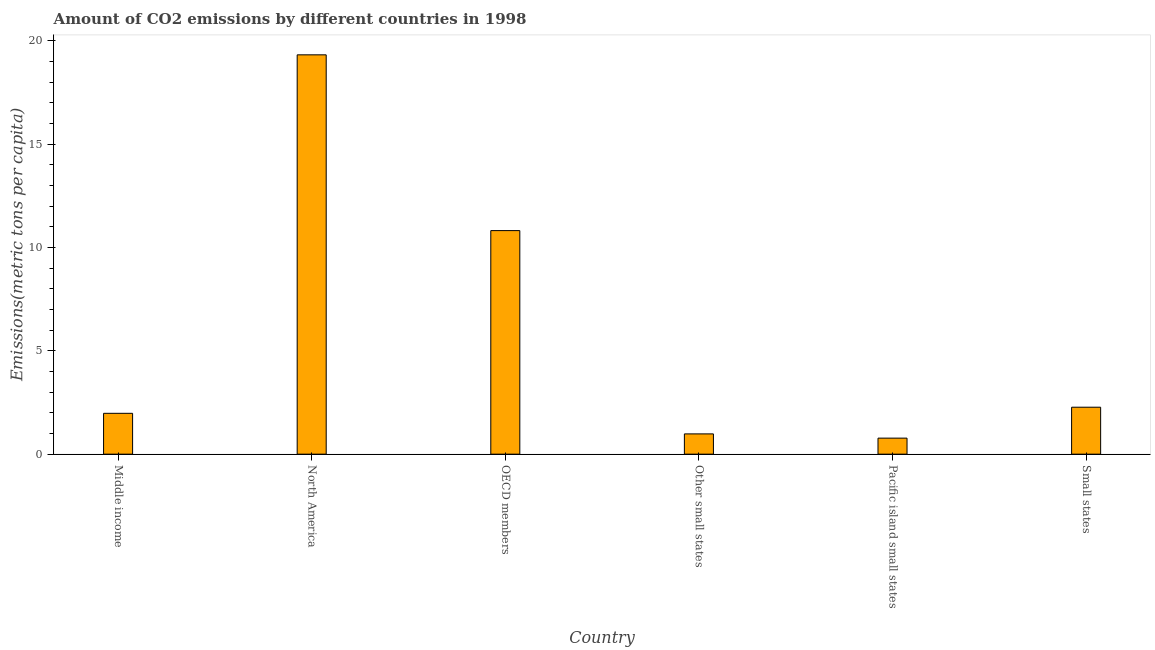Does the graph contain any zero values?
Make the answer very short. No. Does the graph contain grids?
Your answer should be very brief. No. What is the title of the graph?
Ensure brevity in your answer.  Amount of CO2 emissions by different countries in 1998. What is the label or title of the X-axis?
Offer a terse response. Country. What is the label or title of the Y-axis?
Offer a very short reply. Emissions(metric tons per capita). What is the amount of co2 emissions in North America?
Give a very brief answer. 19.33. Across all countries, what is the maximum amount of co2 emissions?
Provide a succinct answer. 19.33. Across all countries, what is the minimum amount of co2 emissions?
Provide a short and direct response. 0.78. In which country was the amount of co2 emissions minimum?
Provide a succinct answer. Pacific island small states. What is the sum of the amount of co2 emissions?
Provide a short and direct response. 36.16. What is the difference between the amount of co2 emissions in Middle income and Pacific island small states?
Your response must be concise. 1.2. What is the average amount of co2 emissions per country?
Provide a short and direct response. 6.03. What is the median amount of co2 emissions?
Ensure brevity in your answer.  2.12. In how many countries, is the amount of co2 emissions greater than 6 metric tons per capita?
Offer a terse response. 2. What is the ratio of the amount of co2 emissions in North America to that in OECD members?
Offer a terse response. 1.79. Is the amount of co2 emissions in Middle income less than that in Small states?
Your answer should be very brief. Yes. Is the difference between the amount of co2 emissions in Pacific island small states and Small states greater than the difference between any two countries?
Provide a short and direct response. No. What is the difference between the highest and the second highest amount of co2 emissions?
Your response must be concise. 8.51. What is the difference between the highest and the lowest amount of co2 emissions?
Provide a succinct answer. 18.55. In how many countries, is the amount of co2 emissions greater than the average amount of co2 emissions taken over all countries?
Offer a terse response. 2. Are all the bars in the graph horizontal?
Ensure brevity in your answer.  No. What is the difference between two consecutive major ticks on the Y-axis?
Offer a very short reply. 5. What is the Emissions(metric tons per capita) in Middle income?
Give a very brief answer. 1.98. What is the Emissions(metric tons per capita) in North America?
Ensure brevity in your answer.  19.33. What is the Emissions(metric tons per capita) in OECD members?
Your answer should be compact. 10.82. What is the Emissions(metric tons per capita) of Other small states?
Your response must be concise. 0.98. What is the Emissions(metric tons per capita) in Pacific island small states?
Provide a succinct answer. 0.78. What is the Emissions(metric tons per capita) of Small states?
Your answer should be compact. 2.27. What is the difference between the Emissions(metric tons per capita) in Middle income and North America?
Keep it short and to the point. -17.35. What is the difference between the Emissions(metric tons per capita) in Middle income and OECD members?
Give a very brief answer. -8.84. What is the difference between the Emissions(metric tons per capita) in Middle income and Other small states?
Make the answer very short. 1. What is the difference between the Emissions(metric tons per capita) in Middle income and Pacific island small states?
Your answer should be compact. 1.2. What is the difference between the Emissions(metric tons per capita) in Middle income and Small states?
Your response must be concise. -0.3. What is the difference between the Emissions(metric tons per capita) in North America and OECD members?
Offer a terse response. 8.51. What is the difference between the Emissions(metric tons per capita) in North America and Other small states?
Keep it short and to the point. 18.35. What is the difference between the Emissions(metric tons per capita) in North America and Pacific island small states?
Make the answer very short. 18.55. What is the difference between the Emissions(metric tons per capita) in North America and Small states?
Keep it short and to the point. 17.06. What is the difference between the Emissions(metric tons per capita) in OECD members and Other small states?
Ensure brevity in your answer.  9.84. What is the difference between the Emissions(metric tons per capita) in OECD members and Pacific island small states?
Provide a short and direct response. 10.05. What is the difference between the Emissions(metric tons per capita) in OECD members and Small states?
Offer a very short reply. 8.55. What is the difference between the Emissions(metric tons per capita) in Other small states and Pacific island small states?
Offer a terse response. 0.21. What is the difference between the Emissions(metric tons per capita) in Other small states and Small states?
Provide a succinct answer. -1.29. What is the difference between the Emissions(metric tons per capita) in Pacific island small states and Small states?
Provide a short and direct response. -1.5. What is the ratio of the Emissions(metric tons per capita) in Middle income to that in North America?
Your answer should be very brief. 0.1. What is the ratio of the Emissions(metric tons per capita) in Middle income to that in OECD members?
Ensure brevity in your answer.  0.18. What is the ratio of the Emissions(metric tons per capita) in Middle income to that in Other small states?
Provide a succinct answer. 2.02. What is the ratio of the Emissions(metric tons per capita) in Middle income to that in Pacific island small states?
Keep it short and to the point. 2.55. What is the ratio of the Emissions(metric tons per capita) in Middle income to that in Small states?
Ensure brevity in your answer.  0.87. What is the ratio of the Emissions(metric tons per capita) in North America to that in OECD members?
Offer a very short reply. 1.79. What is the ratio of the Emissions(metric tons per capita) in North America to that in Pacific island small states?
Ensure brevity in your answer.  24.91. What is the ratio of the Emissions(metric tons per capita) in North America to that in Small states?
Keep it short and to the point. 8.51. What is the ratio of the Emissions(metric tons per capita) in OECD members to that in Other small states?
Provide a short and direct response. 11.03. What is the ratio of the Emissions(metric tons per capita) in OECD members to that in Pacific island small states?
Keep it short and to the point. 13.95. What is the ratio of the Emissions(metric tons per capita) in OECD members to that in Small states?
Ensure brevity in your answer.  4.76. What is the ratio of the Emissions(metric tons per capita) in Other small states to that in Pacific island small states?
Offer a very short reply. 1.26. What is the ratio of the Emissions(metric tons per capita) in Other small states to that in Small states?
Keep it short and to the point. 0.43. What is the ratio of the Emissions(metric tons per capita) in Pacific island small states to that in Small states?
Offer a terse response. 0.34. 